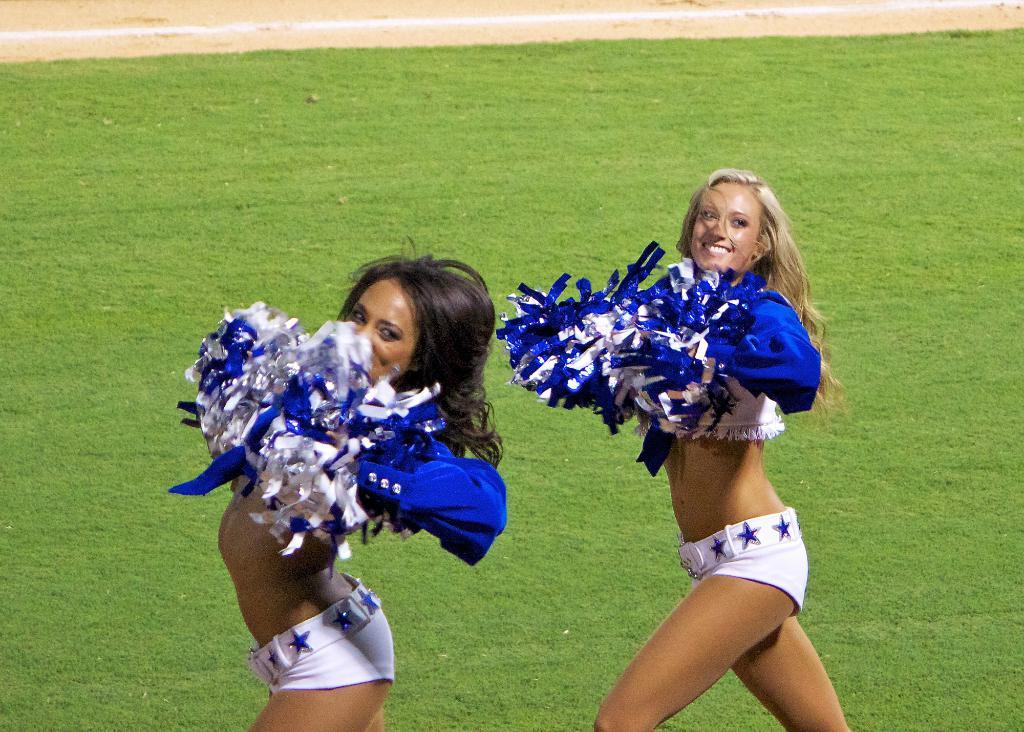How many people are in the image? There are two girls in the image. What are the girls holding in the image? The girls are holding pom poms. What expression do the girls have in the image? The girls are smiling. What can be seen in the background of the image? There is grass visible in the background of the image. Where is the faucet located in the image? There is no faucet present in the image. What type of scarecrow can be seen in the image? There is no scarecrow present in the image. 